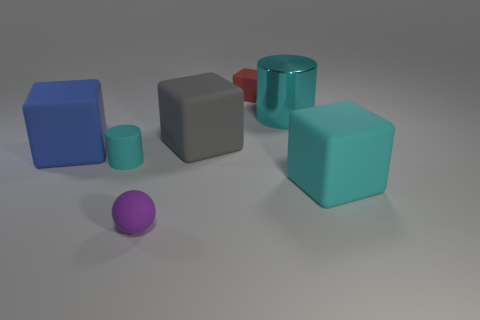Subtract all big gray blocks. How many blocks are left? 3 Subtract all red blocks. How many blocks are left? 3 Add 3 cyan blocks. How many objects exist? 10 Subtract 1 blocks. How many blocks are left? 3 Subtract all balls. How many objects are left? 6 Subtract all cyan balls. Subtract all red cylinders. How many balls are left? 1 Subtract all purple spheres. How many gray blocks are left? 1 Subtract all blue cubes. Subtract all small cyan rubber objects. How many objects are left? 5 Add 4 gray things. How many gray things are left? 5 Add 3 small purple blocks. How many small purple blocks exist? 3 